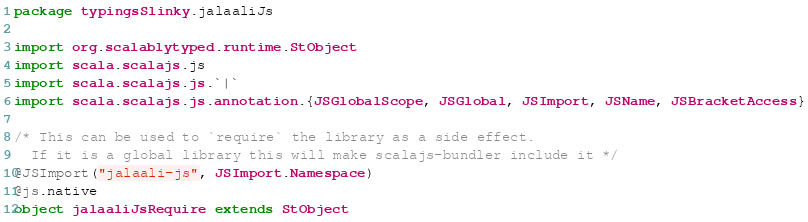<code> <loc_0><loc_0><loc_500><loc_500><_Scala_>package typingsSlinky.jalaaliJs

import org.scalablytyped.runtime.StObject
import scala.scalajs.js
import scala.scalajs.js.`|`
import scala.scalajs.js.annotation.{JSGlobalScope, JSGlobal, JSImport, JSName, JSBracketAccess}

/* This can be used to `require` the library as a side effect.
  If it is a global library this will make scalajs-bundler include it */
@JSImport("jalaali-js", JSImport.Namespace)
@js.native
object jalaaliJsRequire extends StObject
</code> 